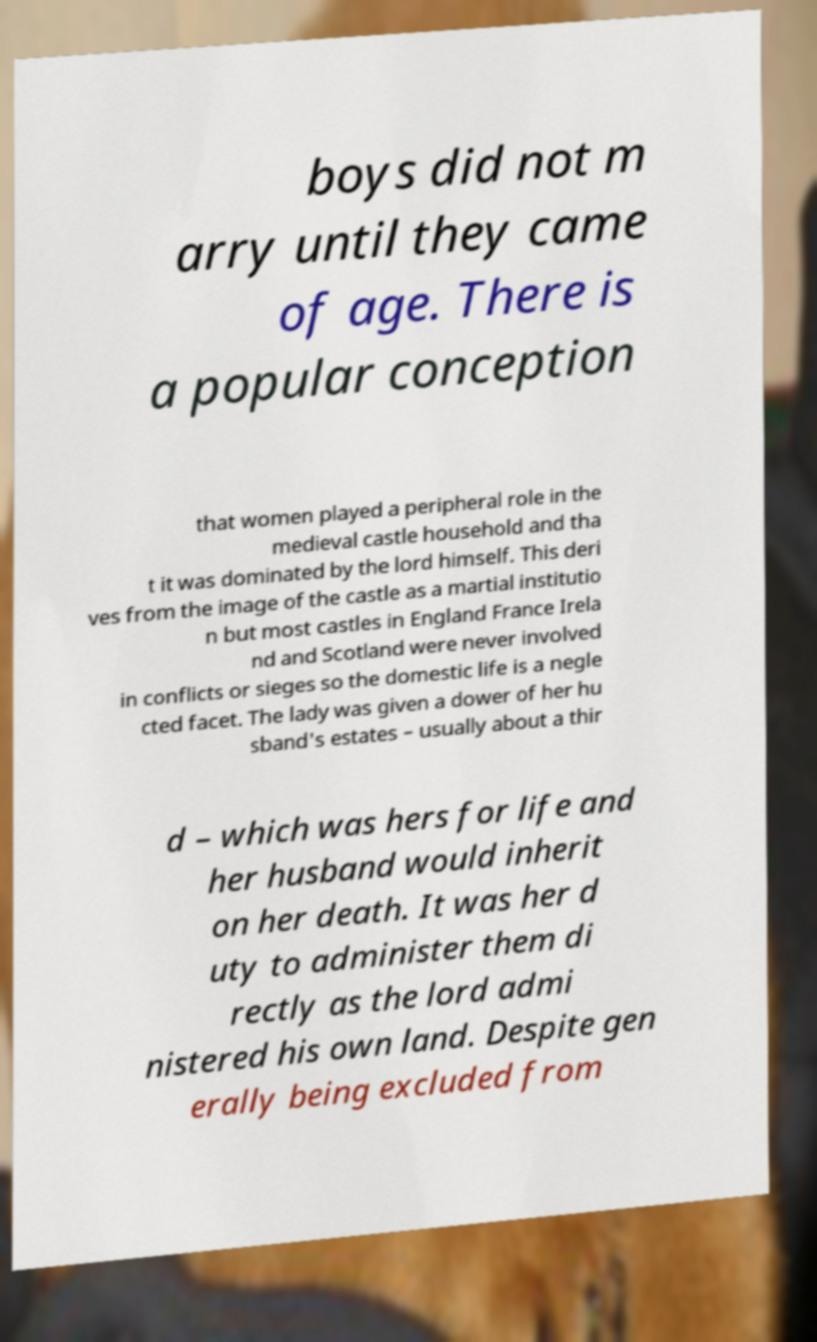Could you assist in decoding the text presented in this image and type it out clearly? boys did not m arry until they came of age. There is a popular conception that women played a peripheral role in the medieval castle household and tha t it was dominated by the lord himself. This deri ves from the image of the castle as a martial institutio n but most castles in England France Irela nd and Scotland were never involved in conflicts or sieges so the domestic life is a negle cted facet. The lady was given a dower of her hu sband's estates – usually about a thir d – which was hers for life and her husband would inherit on her death. It was her d uty to administer them di rectly as the lord admi nistered his own land. Despite gen erally being excluded from 